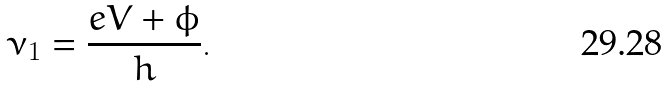<formula> <loc_0><loc_0><loc_500><loc_500>\nu _ { 1 } = \frac { e V + \phi } { h } .</formula> 